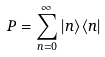Convert formula to latex. <formula><loc_0><loc_0><loc_500><loc_500>P = \sum _ { n = 0 } ^ { \infty } | n \rangle \langle n |</formula> 